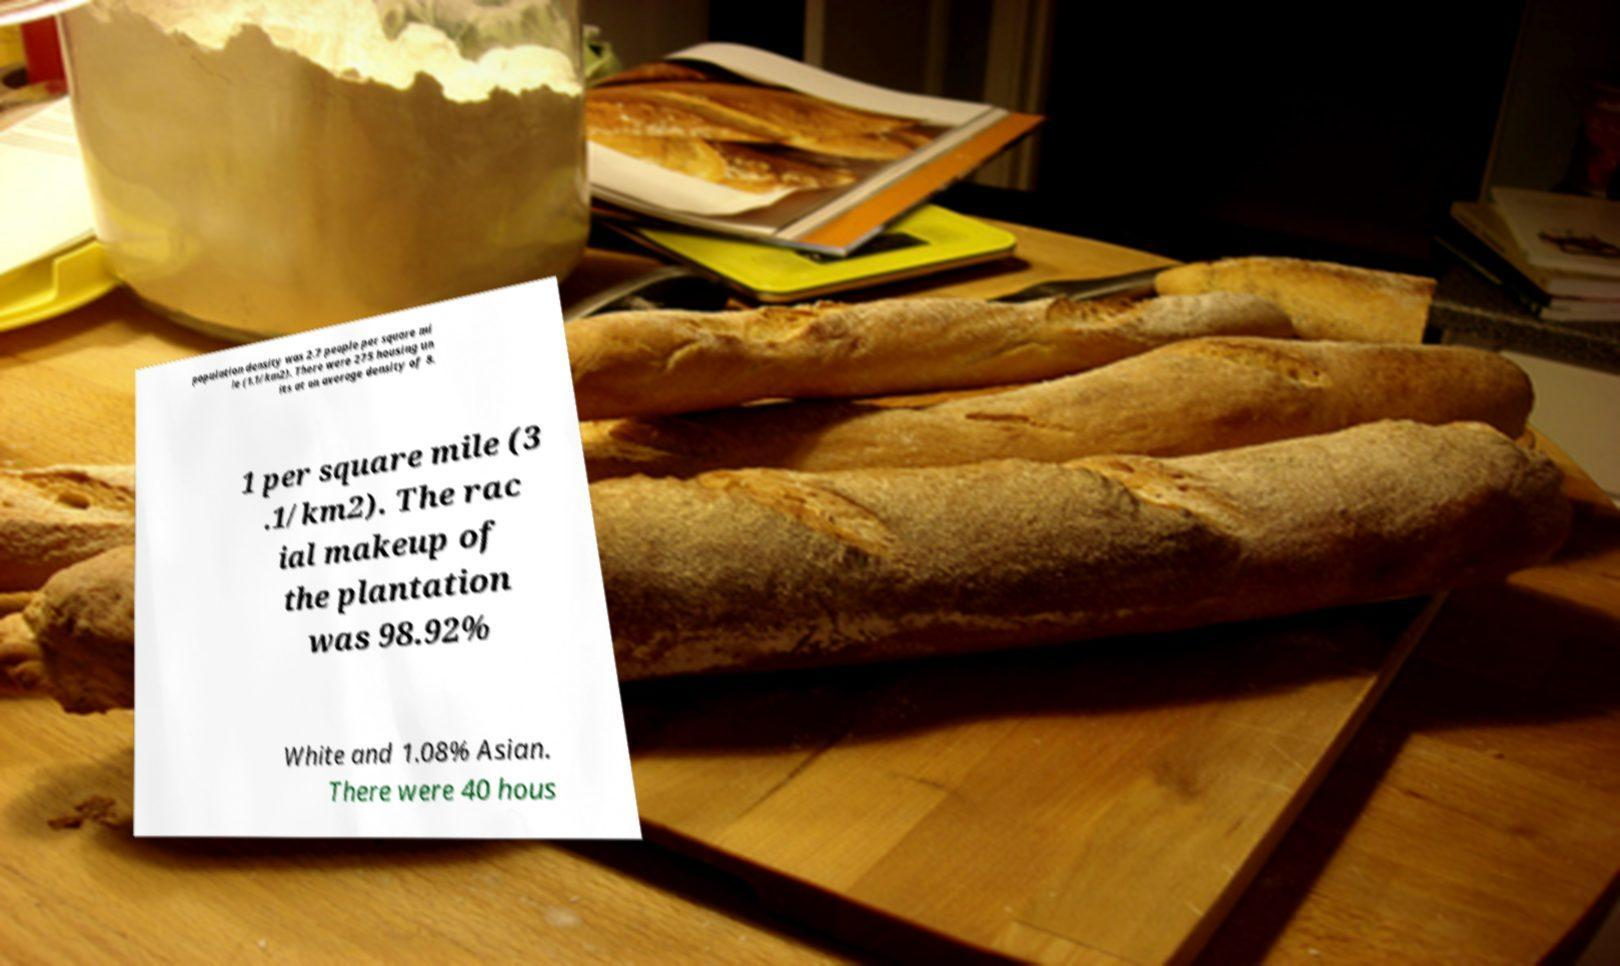I need the written content from this picture converted into text. Can you do that? population density was 2.7 people per square mi le (1.1/km2). There were 275 housing un its at an average density of 8. 1 per square mile (3 .1/km2). The rac ial makeup of the plantation was 98.92% White and 1.08% Asian. There were 40 hous 